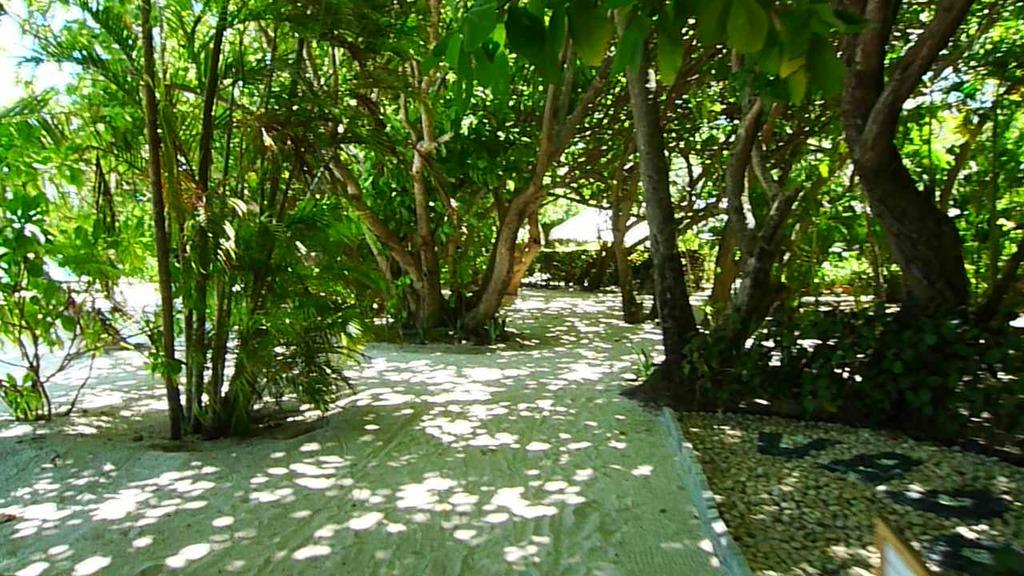What is the main feature in the center of the image? There is a sand walkway in the center of the image. What type of vegetation can be seen on the right side of the image? There are trees and plants on the right side of the image. Are there any trees visible on the left side of the image? Yes, there are trees on the left side of the image. What can be seen in the background of the image? There are trees visible in the background of the image. Can you tell me where the zebra is standing in the image? There is no zebra present in the image. What type of stocking is hanging from the tree on the left side of the image? There is no stocking hanging from the tree on the left side of the image; only trees are visible. 